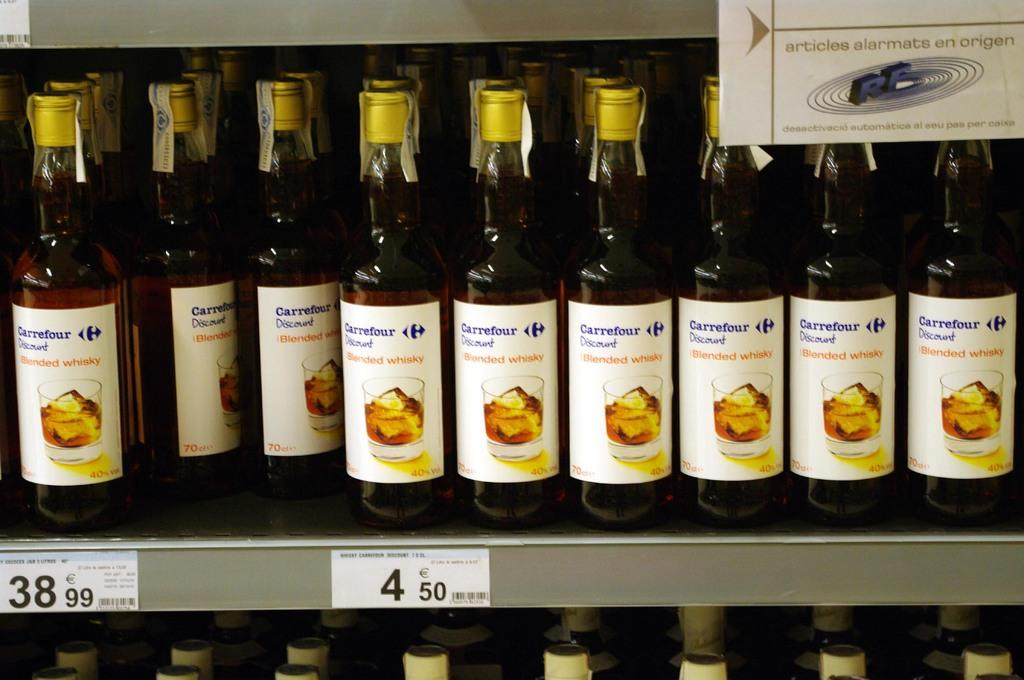What objects are present in the image? There are bottles in the image. How are the bottles arranged? The bottles are arranged in a series. Where are the bottles located in the image? The bottles are located in the center of the image. What is the condition of the partner in the image? There is no partner present in the image; it only features bottles arranged in a series. 